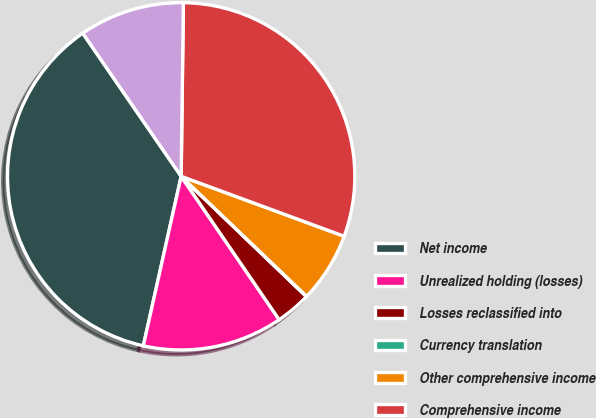<chart> <loc_0><loc_0><loc_500><loc_500><pie_chart><fcel>Net income<fcel>Unrealized holding (losses)<fcel>Losses reclassified into<fcel>Currency translation<fcel>Other comprehensive income<fcel>Comprehensive income<fcel>Comprehensive (income)<nl><fcel>36.92%<fcel>13.04%<fcel>3.28%<fcel>0.03%<fcel>6.54%<fcel>30.41%<fcel>9.79%<nl></chart> 